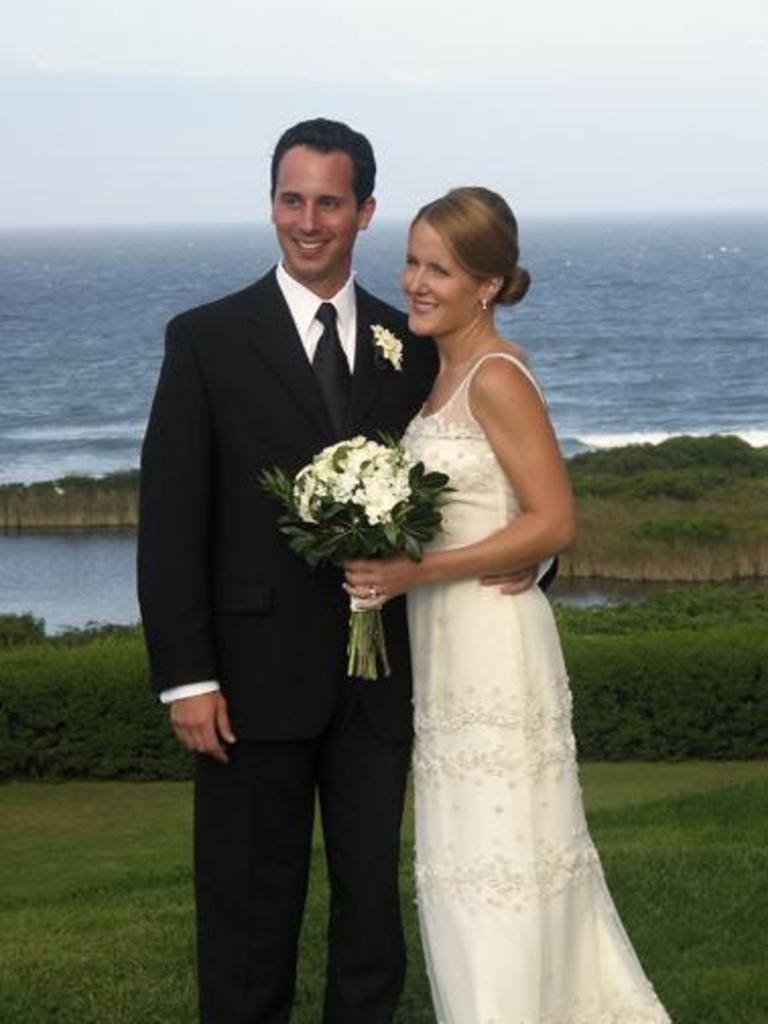Can you describe this image briefly? In the center of the image there is a person wearing black color suit and black color tie. Beside him there is a lady wearing a color dress and holding a flower bouquet in her hand. At the background of the image there is water. At the top of the image there is sky. Bottom of image there is grass. 